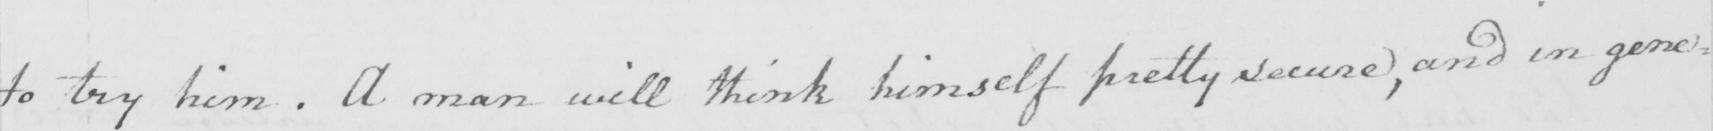What does this handwritten line say? to try him . A man will think himself pretty secure , and in gene= 